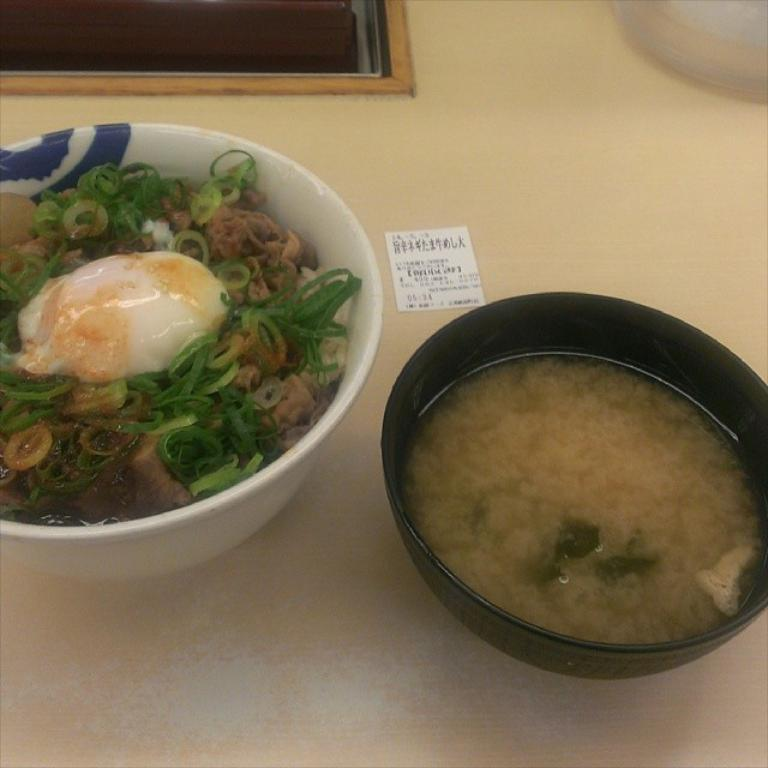What is located in the foreground of the picture? There is a table in the foreground of the picture. What is on the table? There are bowls on the table. What can be found inside the bowls? There are food items in the bowls. What type of silk is draped over the food items in the image? There is no silk present in the image; it features a table with bowls containing food items. 